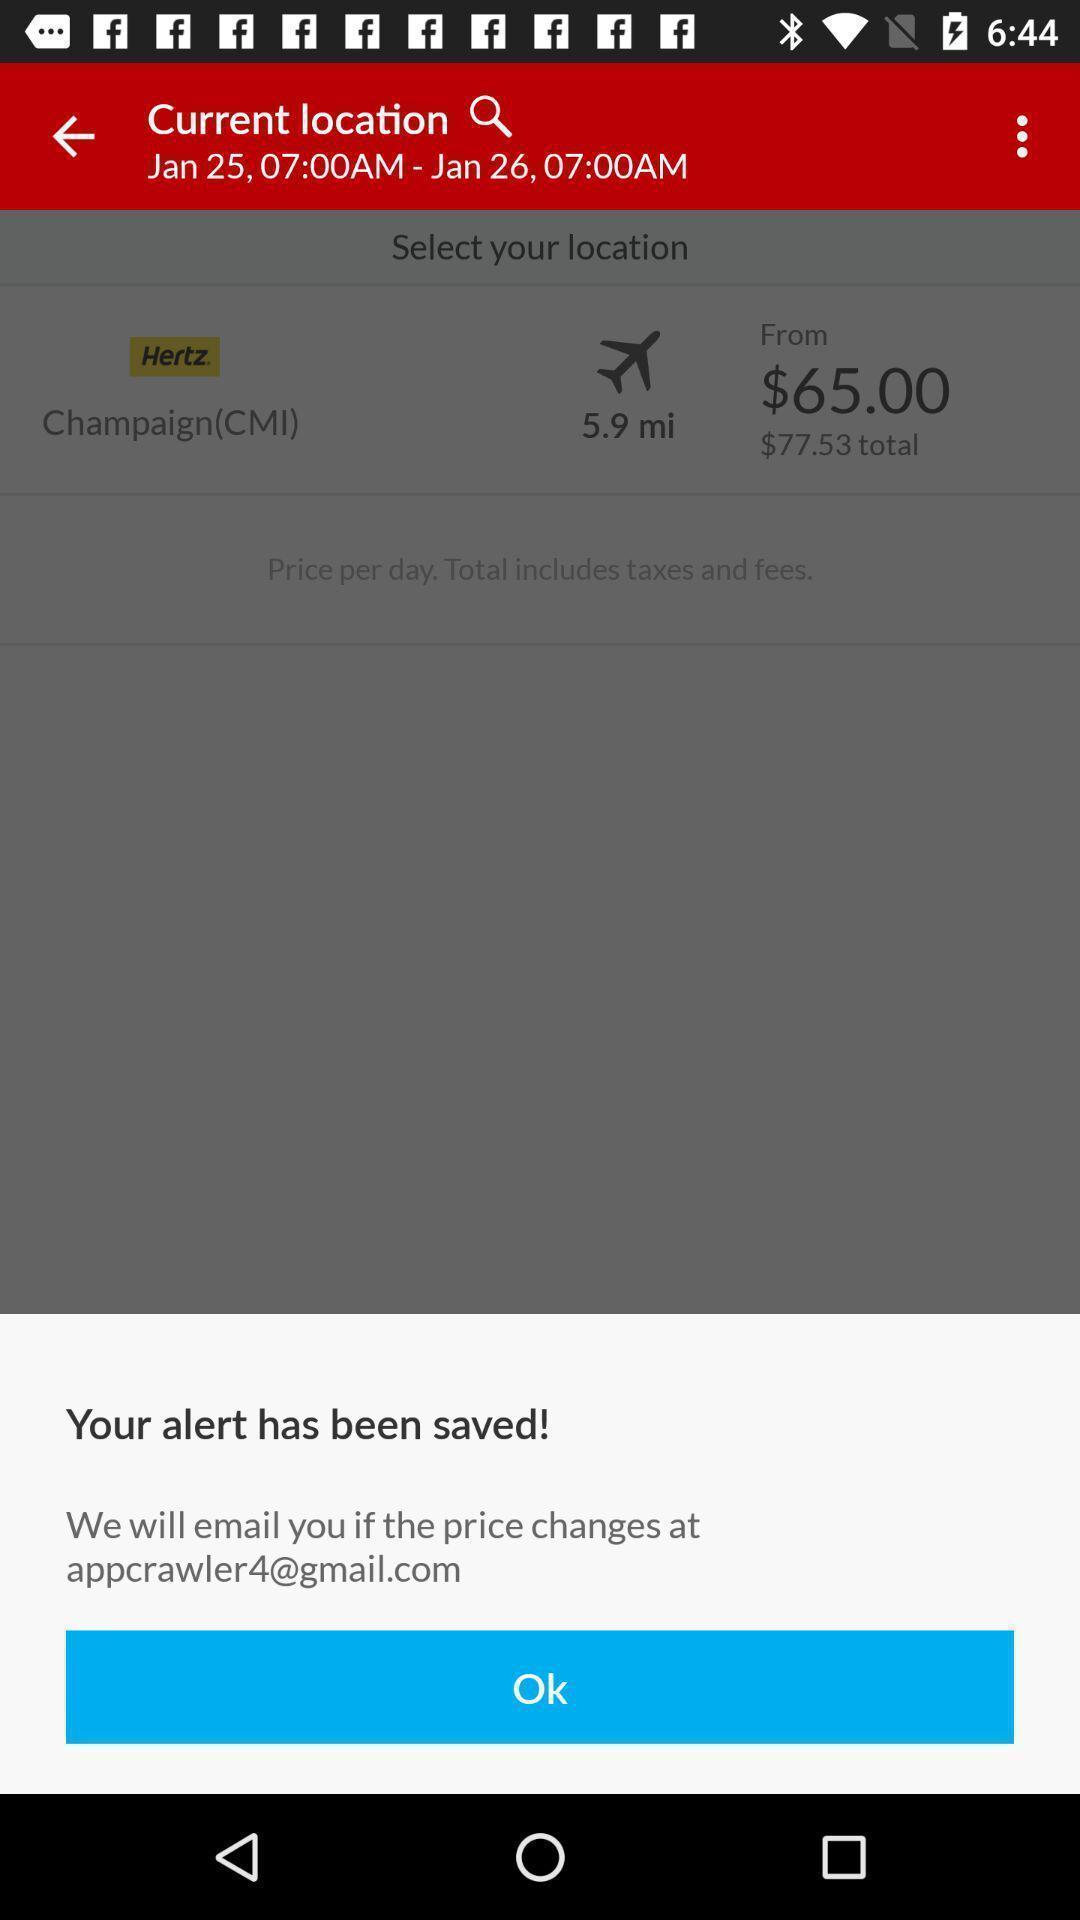Give me a narrative description of this picture. Popup showing the saved information. 